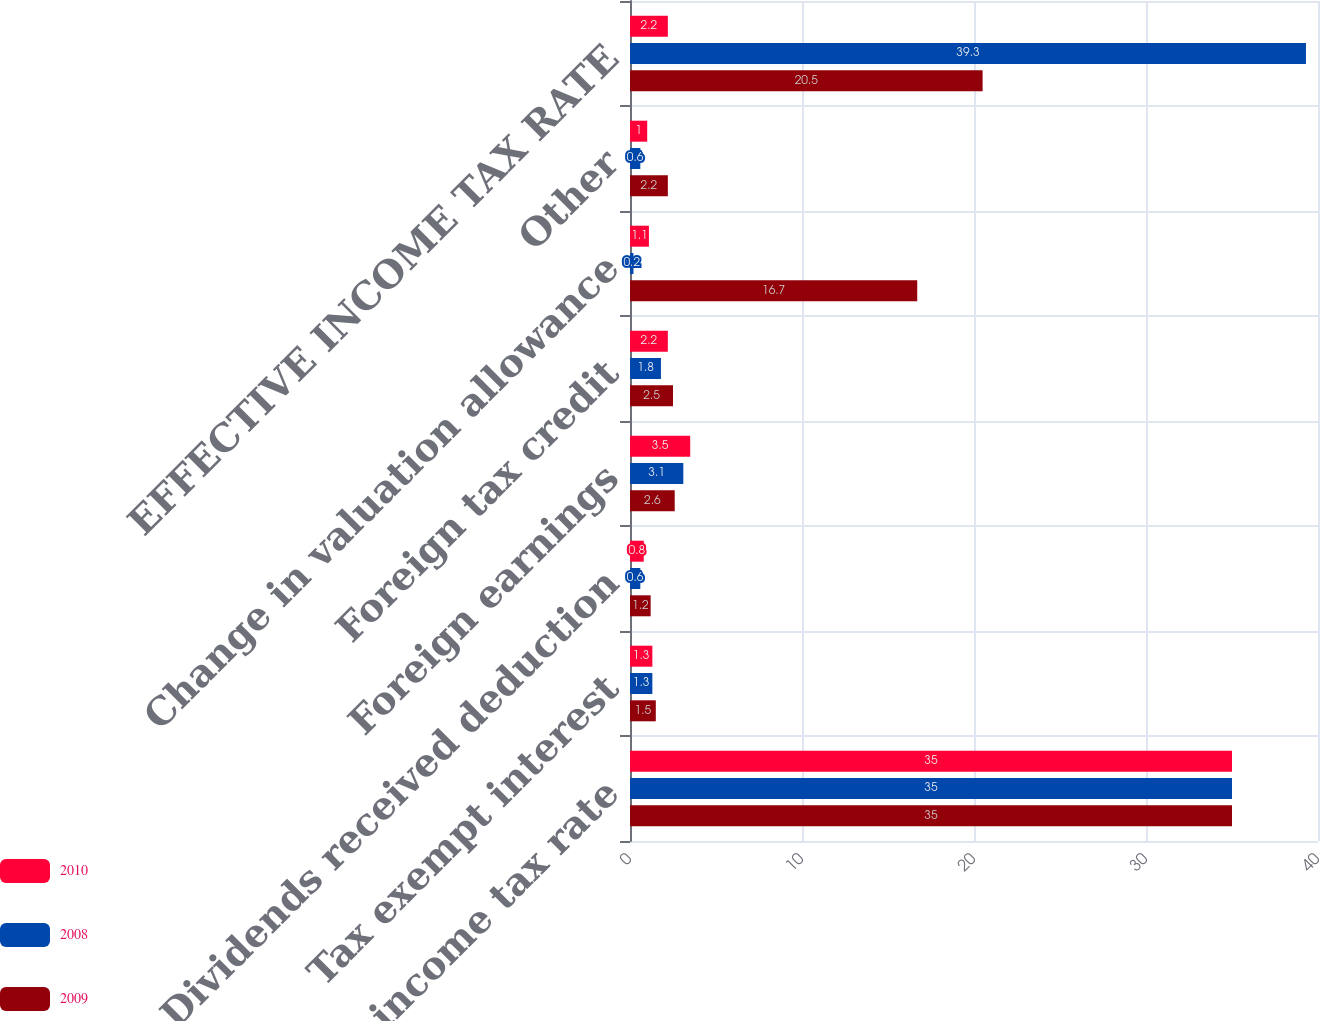Convert chart. <chart><loc_0><loc_0><loc_500><loc_500><stacked_bar_chart><ecel><fcel>Federal income tax rate<fcel>Tax exempt interest<fcel>Dividends received deduction<fcel>Foreign earnings<fcel>Foreign tax credit<fcel>Change in valuation allowance<fcel>Other<fcel>EFFECTIVE INCOME TAX RATE<nl><fcel>2010<fcel>35<fcel>1.3<fcel>0.8<fcel>3.5<fcel>2.2<fcel>1.1<fcel>1<fcel>2.2<nl><fcel>2008<fcel>35<fcel>1.3<fcel>0.6<fcel>3.1<fcel>1.8<fcel>0.2<fcel>0.6<fcel>39.3<nl><fcel>2009<fcel>35<fcel>1.5<fcel>1.2<fcel>2.6<fcel>2.5<fcel>16.7<fcel>2.2<fcel>20.5<nl></chart> 